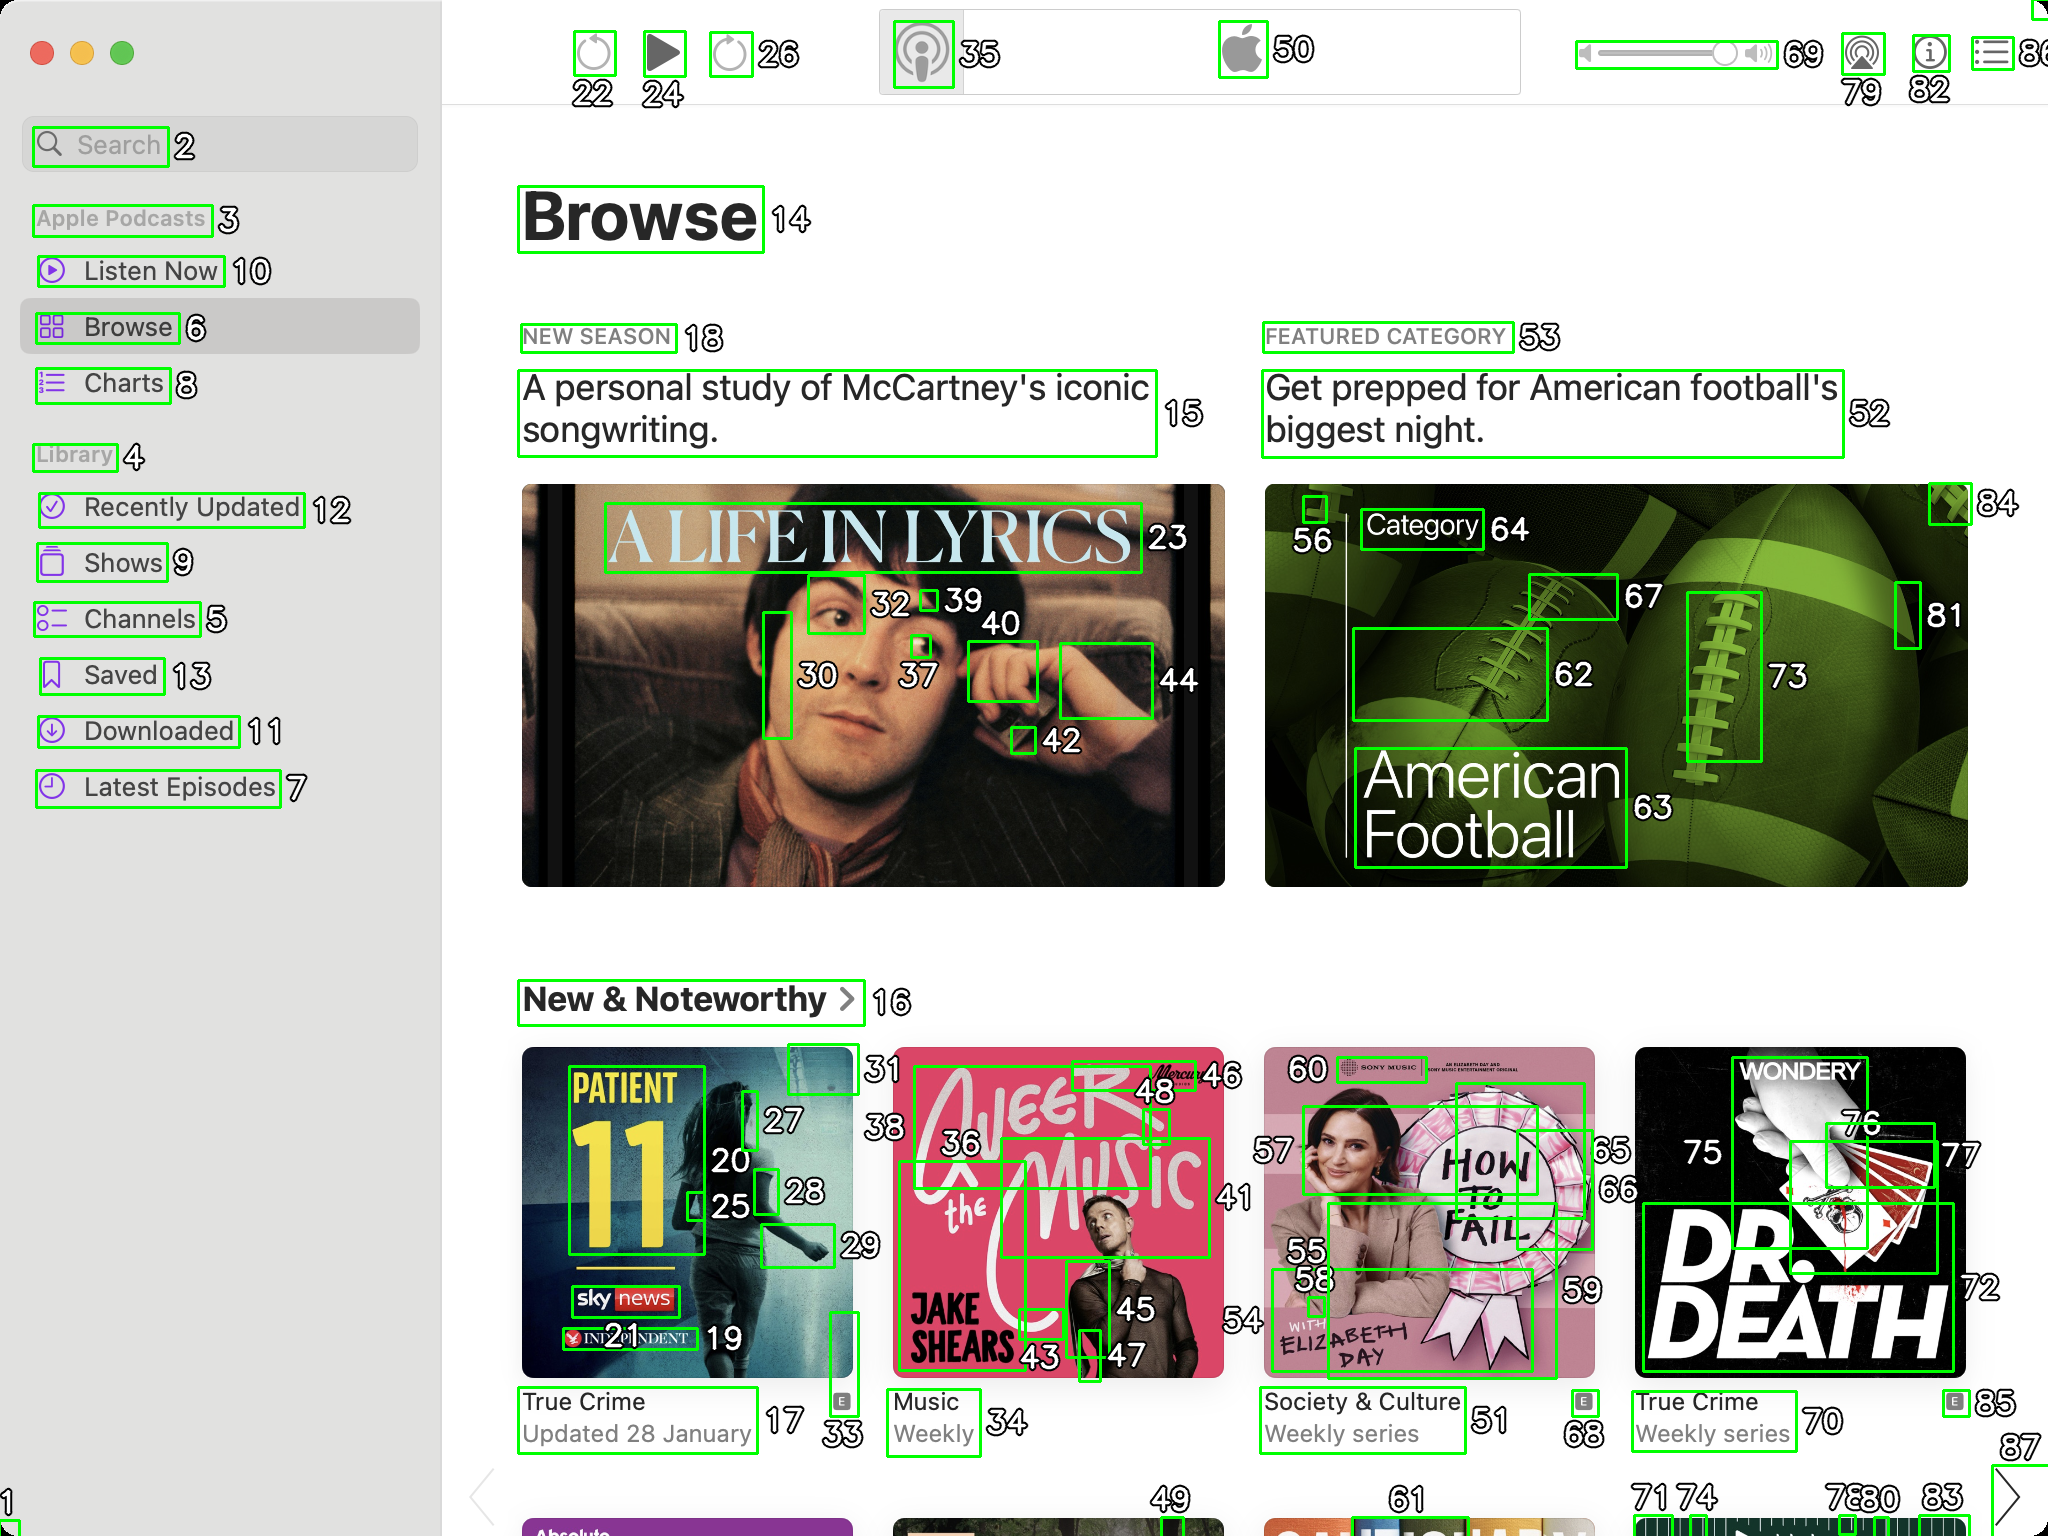You are an AI designed for image processing and segmentation analysis, particularly skilled in merging segmented regions of an image to improve accuracy and readability.

**Task Description:**
Your task is to address a user's concern with a UI screenshot of the Apple Podcasts application on MacOS. The screenshot contains multiple green boxes, each representing a UI element, with a unique white number outlined in black ranging from 1 to 88. Due to segmentation issues, some boxes that belong to the same image are divided unnaturally.

**Objective:**
Merge these segmented areas that correspond to a single UI element to create a coherent representation. The final output should be in JSON format, where each key-value pair represents the merged areas.

**Example JSON Output:**
If boxes with numbers 1, 2, and 3 should belong to the same UI element, the JSON output should be:

```json
{
    "Image A Life In Lyrics": [1, 2, 3]
}
```

**Instructions:**

- **Identify Segmented Regions:** Analyze the screenshot to identify which green boxes belong to the same UI element.
- **Merge Regions:** Group the numbers of these boxes together to represent a single UI element.
- **Output Format:** Produce the output in JSON format, with each key representing a UI element and each value being a list of the numbers of the merged boxes. Don't include in the result UI elements that consist of one box.

**Primary Objective:**
Ensure the accuracy of the merged regions based on the user's supplied image information, maintaining the integrity and structure of the UI elements in the Apple Podcasts application on MacOS. ```json
{
    "A Life In Lyrics": [23, 30, 32, 37, 39, 40, 42, 44],
    "American Football": [52, 53, 62, 63, 64, 73, 81, 84],
    "Patient 11": [17, 20, 21, 25, 27, 28, 33],
    "A Life In The Music": [36, 43, 45, 46, 48],
    "How To Fail": [55, 56, 58, 59, 60],
    "Dr. Death": [70, 71, 72, 75, 76, 77, 78, 80, 85]
}
``` 